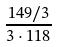Convert formula to latex. <formula><loc_0><loc_0><loc_500><loc_500>\frac { 1 4 9 / 3 } { 3 \cdot 1 1 8 }</formula> 